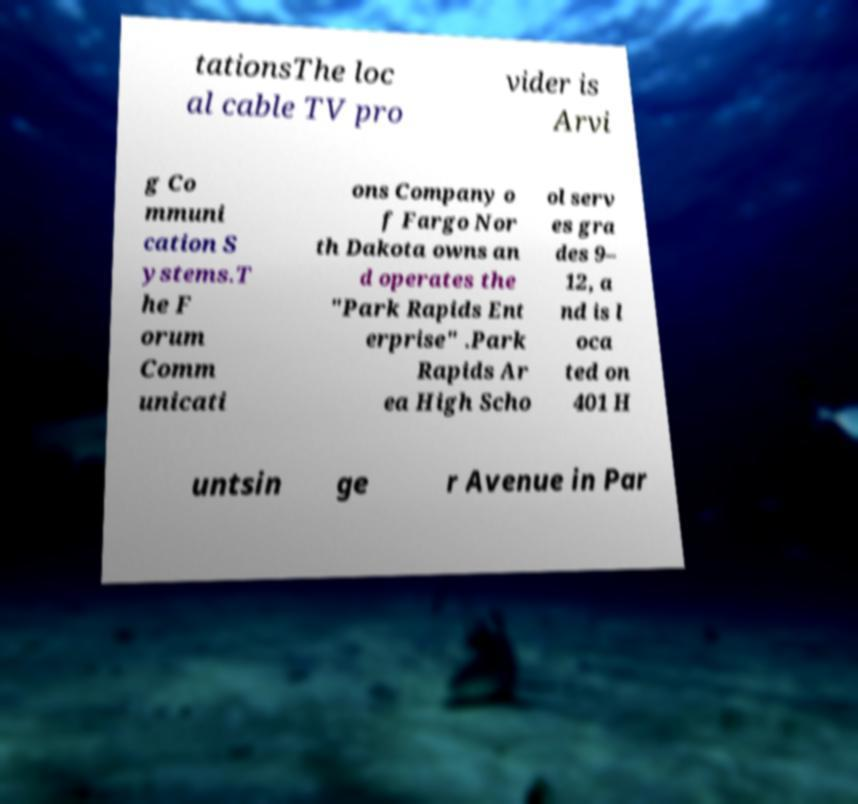Please read and relay the text visible in this image. What does it say? tationsThe loc al cable TV pro vider is Arvi g Co mmuni cation S ystems.T he F orum Comm unicati ons Company o f Fargo Nor th Dakota owns an d operates the "Park Rapids Ent erprise" .Park Rapids Ar ea High Scho ol serv es gra des 9– 12, a nd is l oca ted on 401 H untsin ge r Avenue in Par 